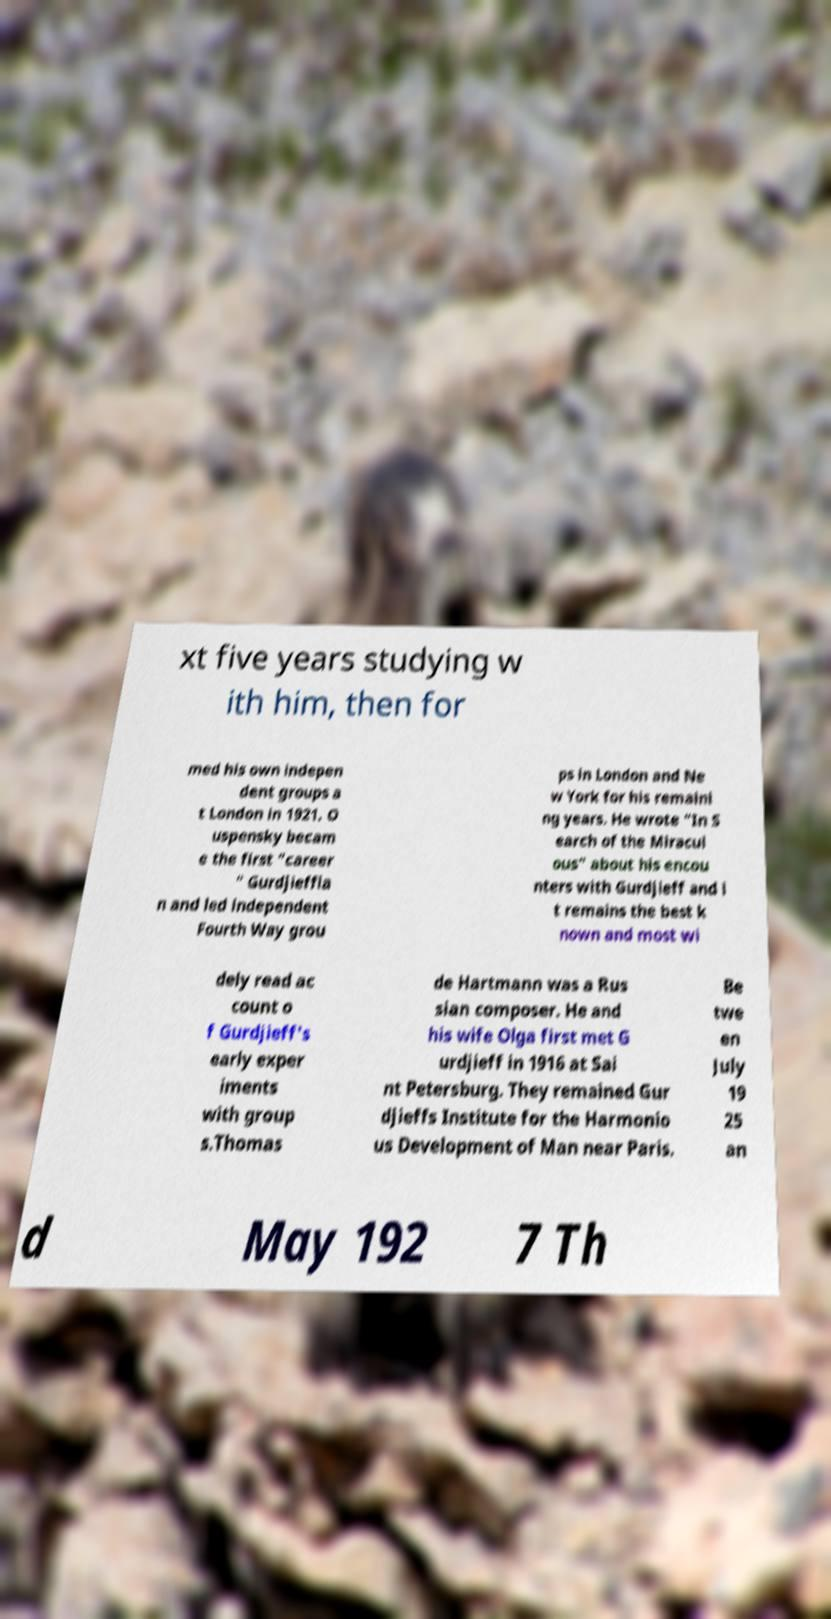For documentation purposes, I need the text within this image transcribed. Could you provide that? xt five years studying w ith him, then for med his own indepen dent groups a t London in 1921. O uspensky becam e the first "career " Gurdjieffia n and led independent Fourth Way grou ps in London and Ne w York for his remaini ng years. He wrote "In S earch of the Miracul ous" about his encou nters with Gurdjieff and i t remains the best k nown and most wi dely read ac count o f Gurdjieff's early exper iments with group s.Thomas de Hartmann was a Rus sian composer. He and his wife Olga first met G urdjieff in 1916 at Sai nt Petersburg. They remained Gur djieffs Institute for the Harmonio us Development of Man near Paris. Be twe en July 19 25 an d May 192 7 Th 